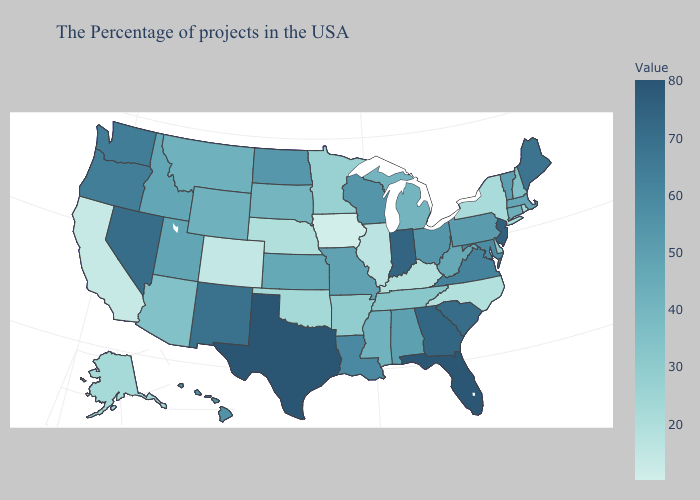Is the legend a continuous bar?
Quick response, please. Yes. Does Iowa have the lowest value in the USA?
Give a very brief answer. Yes. Is the legend a continuous bar?
Be succinct. Yes. 